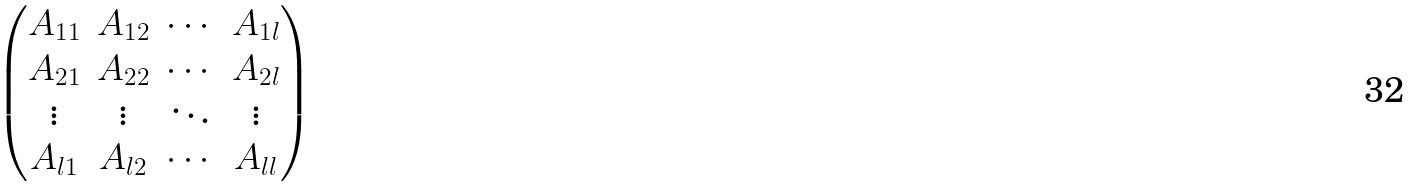<formula> <loc_0><loc_0><loc_500><loc_500>\begin{pmatrix} A _ { 1 1 } & A _ { 1 2 } & \cdots & A _ { 1 l } \\ A _ { 2 1 } & A _ { 2 2 } & \cdots & A _ { 2 l } \\ \vdots & \vdots & \ddots & \vdots \\ A _ { l 1 } & A _ { l 2 } & \cdots & A _ { l l } \end{pmatrix}</formula> 